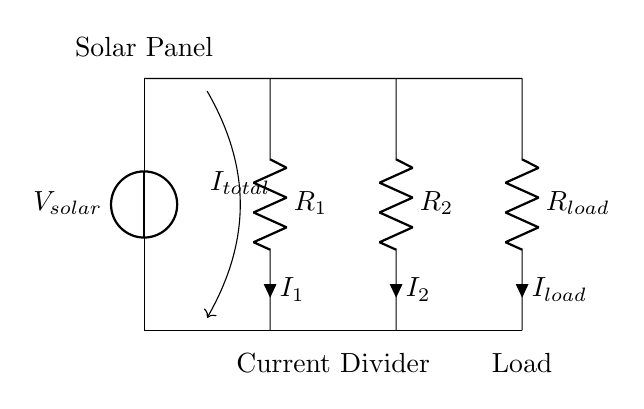What is the source of voltage in this circuit? The source of voltage is the solar panel, indicated as V\(_{solar}\) in the diagram. This component provides the electrical energy for the circuit.
Answer: solar panel What components are part of the current divider? The current divider is made up of two resistors, labeled R\(_1\) and R\(_2\), connected in parallel. They divide the total current into two branches.
Answer: R1 and R2 What does R\(_{load}\) represent in this circuit? R\(_{load}\) represents the load in the circuit, which draws current from the divided paths coming from R\(_1\) and R\(_2\). This indicates where the output of the current divider is used.
Answer: load How is the total current distributed across R\(_1\) and R\(_2\)? The total current divides according to the resistance values of R\(_1\) and R\(_2\). According to the current divider rule, the current through each resistor is inversely proportional to its resistance.
Answer: inversely proportional What is the role of the solar panel in this circuit? The solar panel acts as the source that converts solar energy into electrical energy, providing the voltage and current needed for the circuit to operate.
Answer: energy source What would happen if R\(_1\) is much smaller than R\(_2\)? If R\(_1\) is much smaller than R\(_2\), most of the total current will flow through R\(_1\), resulting in a much larger current for R\(_1\) compared to R\(_2\) due to the current divider principle.
Answer: more current through R1 